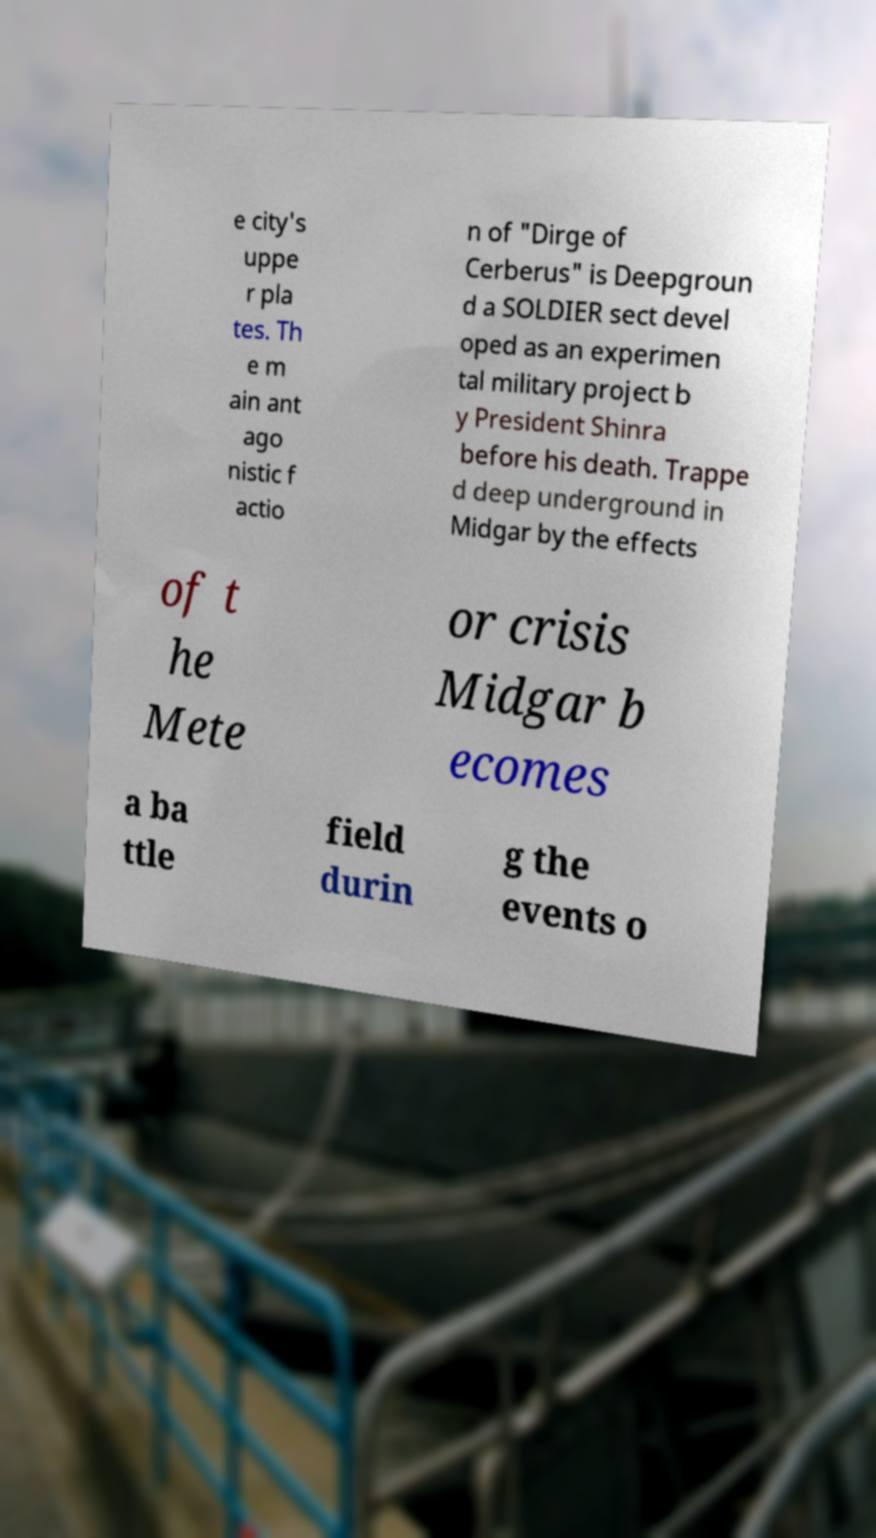For documentation purposes, I need the text within this image transcribed. Could you provide that? e city's uppe r pla tes. Th e m ain ant ago nistic f actio n of "Dirge of Cerberus" is Deepgroun d a SOLDIER sect devel oped as an experimen tal military project b y President Shinra before his death. Trappe d deep underground in Midgar by the effects of t he Mete or crisis Midgar b ecomes a ba ttle field durin g the events o 